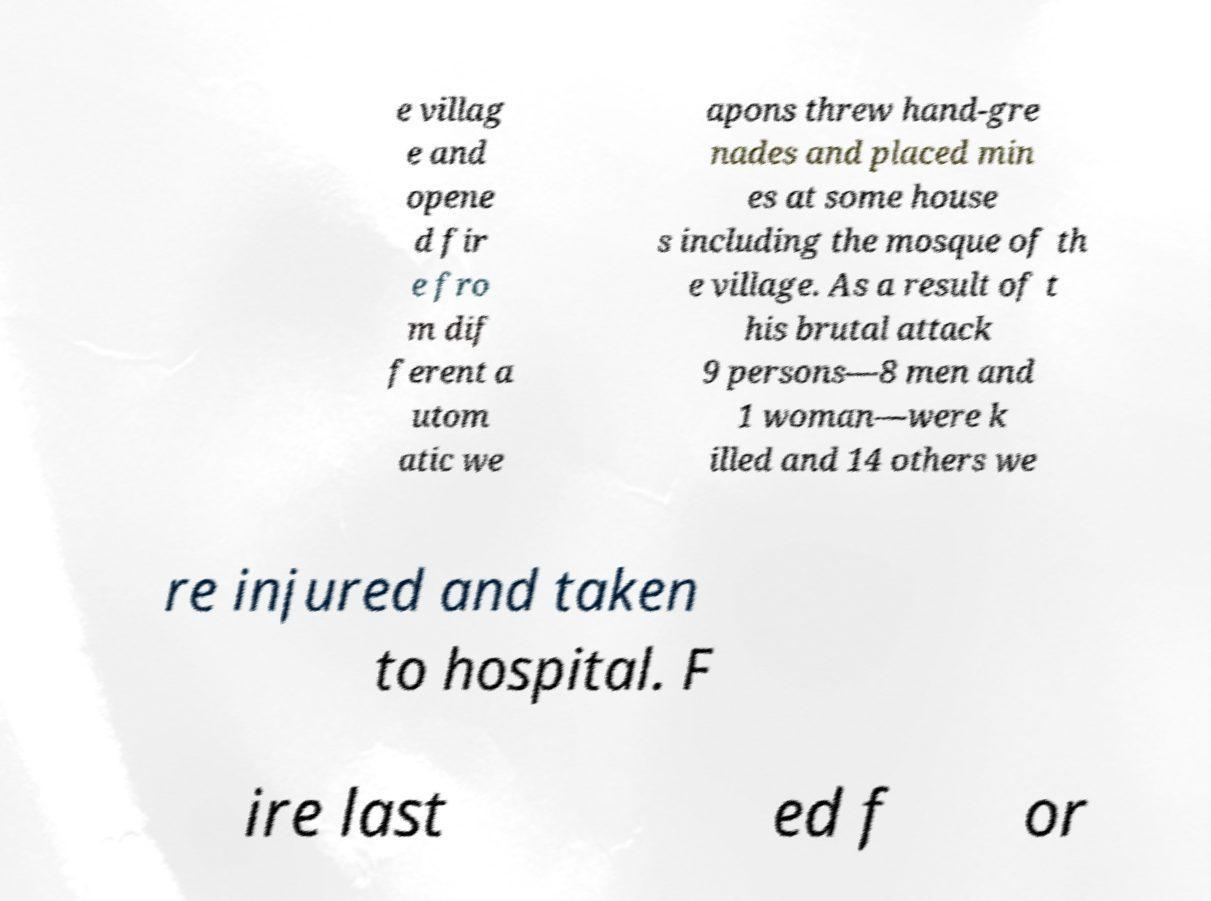What messages or text are displayed in this image? I need them in a readable, typed format. e villag e and opene d fir e fro m dif ferent a utom atic we apons threw hand-gre nades and placed min es at some house s including the mosque of th e village. As a result of t his brutal attack 9 persons—8 men and 1 woman—were k illed and 14 others we re injured and taken to hospital. F ire last ed f or 